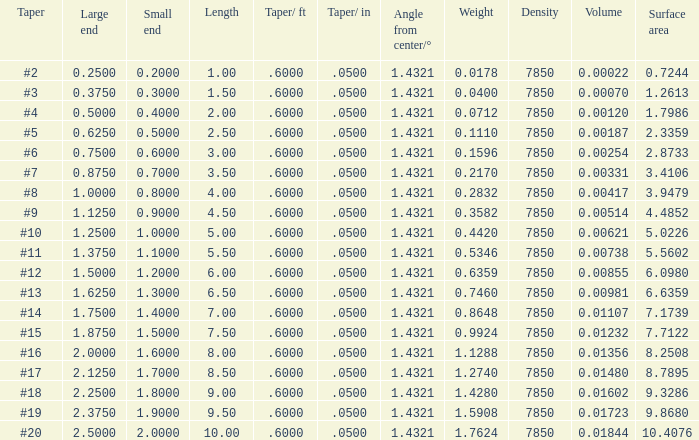Which Large end has a Taper/ft smaller than 0.6000000000000001? 19.0. 